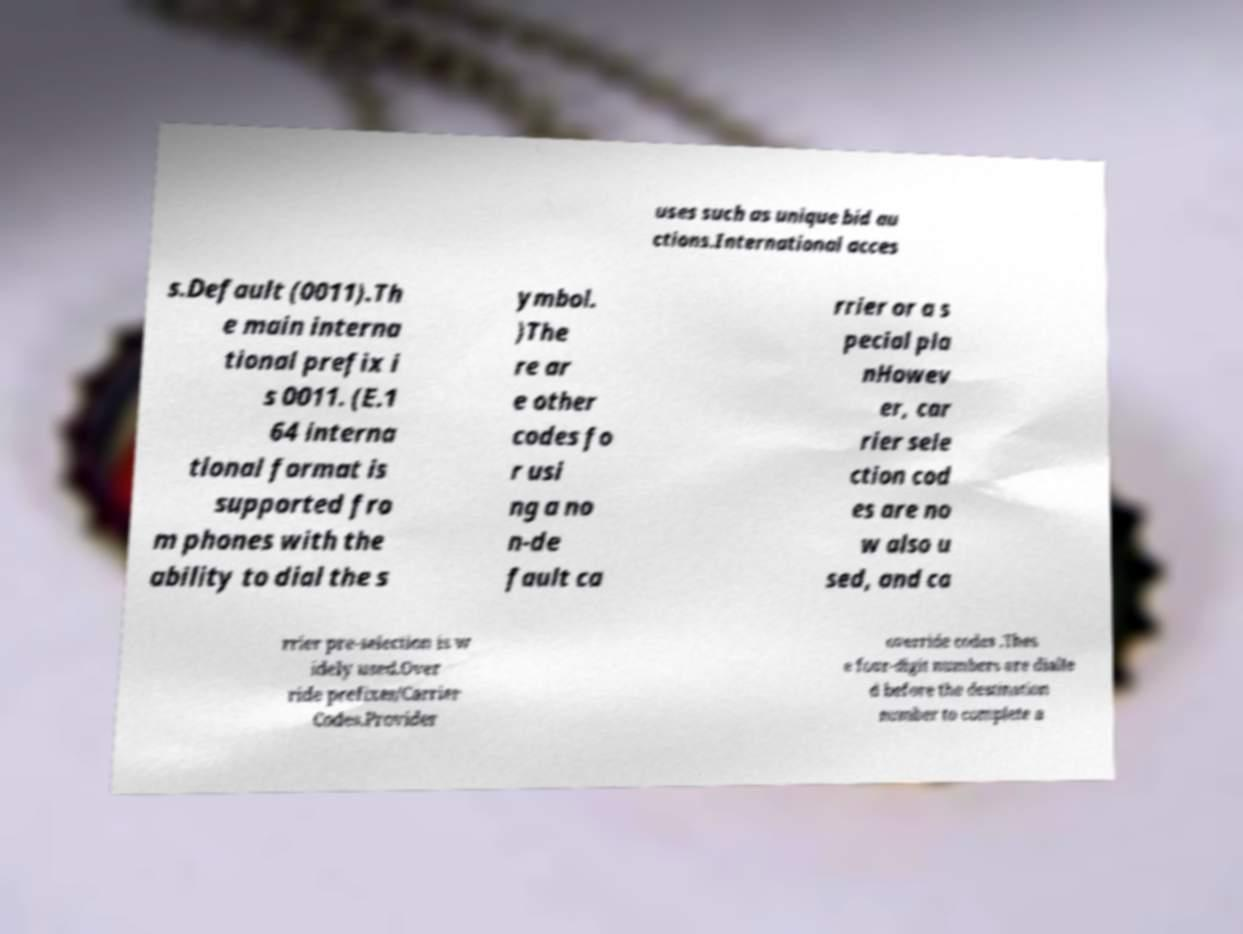There's text embedded in this image that I need extracted. Can you transcribe it verbatim? uses such as unique bid au ctions.International acces s.Default (0011).Th e main interna tional prefix i s 0011. (E.1 64 interna tional format is supported fro m phones with the ability to dial the s ymbol. )The re ar e other codes fo r usi ng a no n-de fault ca rrier or a s pecial pla nHowev er, car rier sele ction cod es are no w also u sed, and ca rrier pre-selection is w idely used.Over ride prefixes/Carrier Codes.Provider override codes .Thes e four-digit numbers are dialle d before the destination number to complete a 